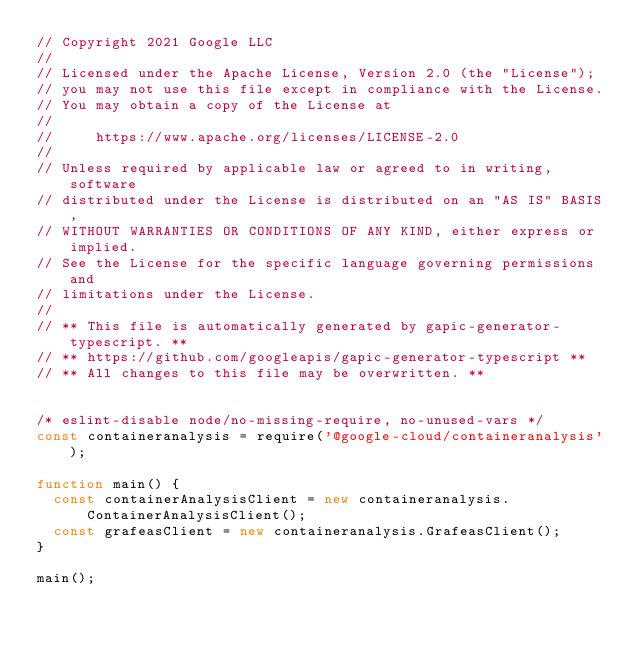<code> <loc_0><loc_0><loc_500><loc_500><_JavaScript_>// Copyright 2021 Google LLC
//
// Licensed under the Apache License, Version 2.0 (the "License");
// you may not use this file except in compliance with the License.
// You may obtain a copy of the License at
//
//     https://www.apache.org/licenses/LICENSE-2.0
//
// Unless required by applicable law or agreed to in writing, software
// distributed under the License is distributed on an "AS IS" BASIS,
// WITHOUT WARRANTIES OR CONDITIONS OF ANY KIND, either express or implied.
// See the License for the specific language governing permissions and
// limitations under the License.
//
// ** This file is automatically generated by gapic-generator-typescript. **
// ** https://github.com/googleapis/gapic-generator-typescript **
// ** All changes to this file may be overwritten. **


/* eslint-disable node/no-missing-require, no-unused-vars */
const containeranalysis = require('@google-cloud/containeranalysis');

function main() {
  const containerAnalysisClient = new containeranalysis.ContainerAnalysisClient();
  const grafeasClient = new containeranalysis.GrafeasClient();
}

main();
</code> 